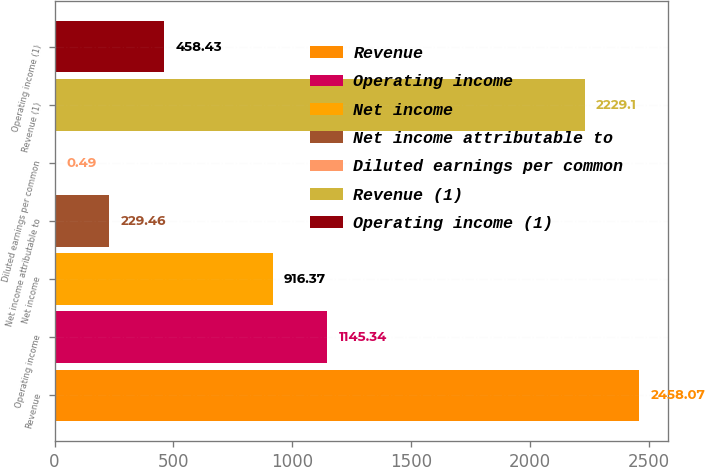Convert chart. <chart><loc_0><loc_0><loc_500><loc_500><bar_chart><fcel>Revenue<fcel>Operating income<fcel>Net income<fcel>Net income attributable to<fcel>Diluted earnings per common<fcel>Revenue (1)<fcel>Operating income (1)<nl><fcel>2458.07<fcel>1145.34<fcel>916.37<fcel>229.46<fcel>0.49<fcel>2229.1<fcel>458.43<nl></chart> 